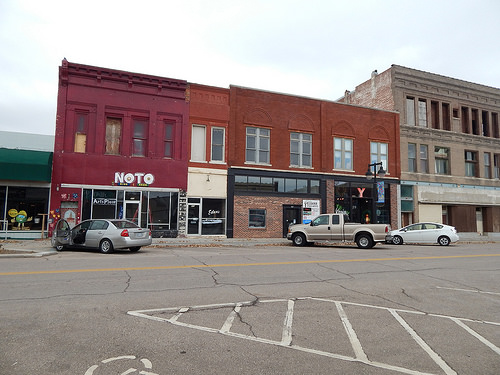<image>
Is the truck in the store? No. The truck is not contained within the store. These objects have a different spatial relationship. 